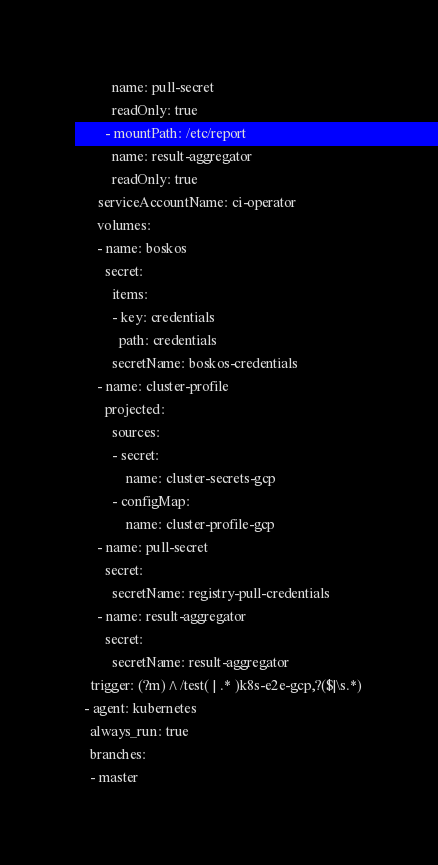<code> <loc_0><loc_0><loc_500><loc_500><_YAML_>          name: pull-secret
          readOnly: true
        - mountPath: /etc/report
          name: result-aggregator
          readOnly: true
      serviceAccountName: ci-operator
      volumes:
      - name: boskos
        secret:
          items:
          - key: credentials
            path: credentials
          secretName: boskos-credentials
      - name: cluster-profile
        projected:
          sources:
          - secret:
              name: cluster-secrets-gcp
          - configMap:
              name: cluster-profile-gcp
      - name: pull-secret
        secret:
          secretName: registry-pull-credentials
      - name: result-aggregator
        secret:
          secretName: result-aggregator
    trigger: (?m)^/test( | .* )k8s-e2e-gcp,?($|\s.*)
  - agent: kubernetes
    always_run: true
    branches:
    - master</code> 